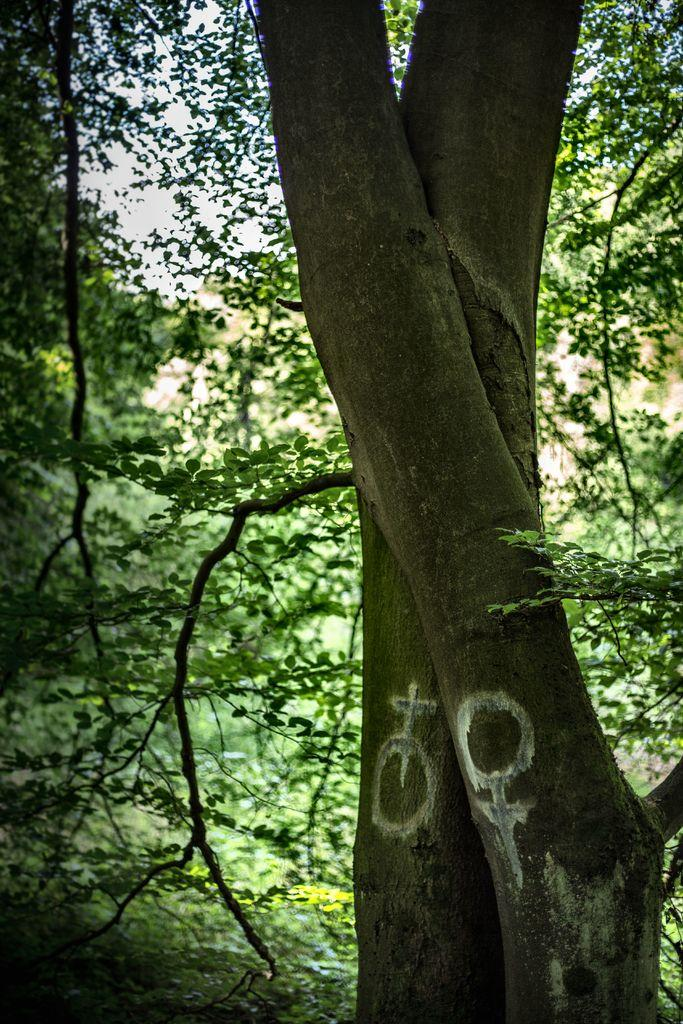What is the main subject of the image? The main subject of the image is a tree trunk. What is unique about the tree trunk? The tree trunk has white paint on it. What can be seen in the background of the image? There are plants and trees visible in the background of the image. What type of hospital is depicted in the image? There is no hospital present in the image; it features a tree trunk with white paint on it. What is the scarecrow doing in the image? There is no scarecrow present in the image. 